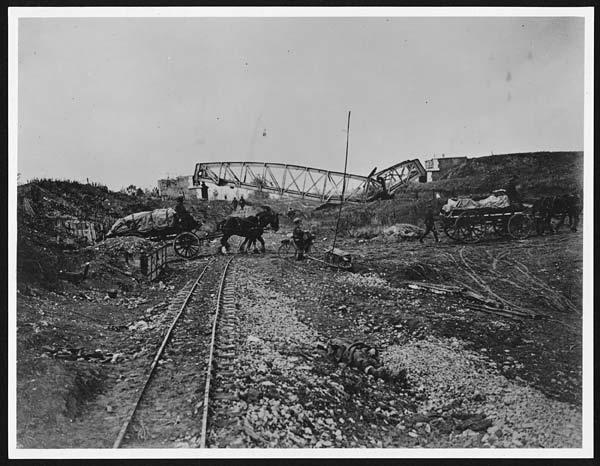Is this photo annotated?
Answer briefly. No. Is the photo in black and white?
Give a very brief answer. Yes. Can you cross the tracks now?
Be succinct. Yes. What type of transportation can be found here?
Concise answer only. Horse and carriage. Can people walk on this bridge?
Keep it brief. No. What is the farthest man standing on?
Concise answer only. Dirt. What types of activities are being conducted on the railway?
Concise answer only. Construction. Is this a black and white photo?
Answer briefly. Yes. 